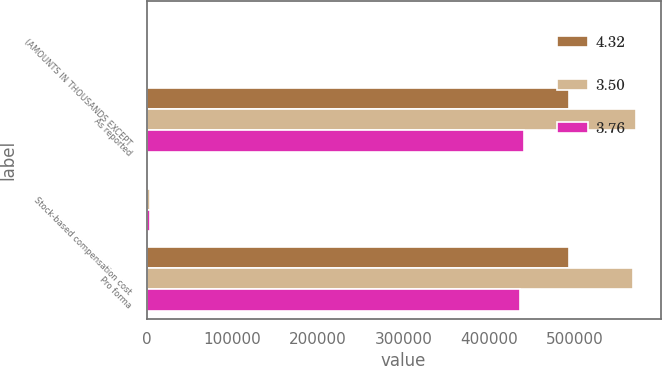Convert chart. <chart><loc_0><loc_0><loc_500><loc_500><stacked_bar_chart><ecel><fcel>(AMOUNTS IN THOUSANDS EXCEPT<fcel>As reported<fcel>Stock-based compensation cost<fcel>Pro forma<nl><fcel>4.32<fcel>2005<fcel>493103<fcel>337<fcel>492766<nl><fcel>3.5<fcel>2004<fcel>570997<fcel>3952<fcel>567045<nl><fcel>3.76<fcel>2003<fcel>439888<fcel>4460<fcel>435428<nl></chart> 